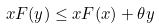<formula> <loc_0><loc_0><loc_500><loc_500>x F ( y ) \leq x F ( x ) + \theta y</formula> 